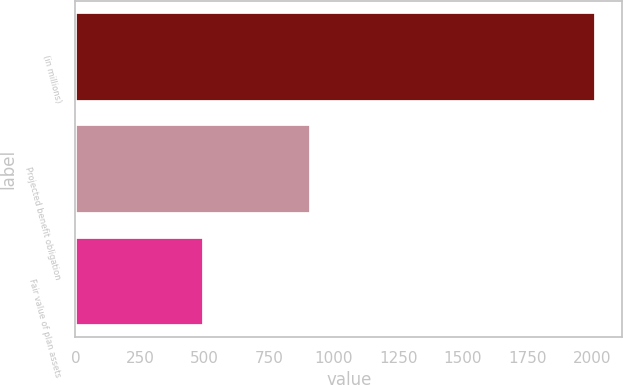<chart> <loc_0><loc_0><loc_500><loc_500><bar_chart><fcel>(in millions)<fcel>Projected benefit obligation<fcel>Fair value of plan assets<nl><fcel>2015<fcel>912<fcel>497<nl></chart> 